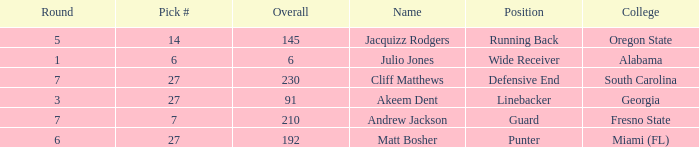Which overall's pick number was 14? 145.0. 